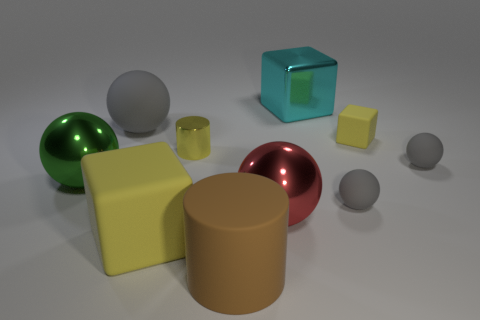What is the shape of the big rubber object that is the same color as the small metallic cylinder?
Make the answer very short. Cube. What number of cylinders are either big gray things or cyan shiny things?
Provide a succinct answer. 0. What number of gray objects have the same material as the yellow cylinder?
Provide a succinct answer. 0. Is the material of the block behind the big gray matte ball the same as the big thing in front of the big yellow thing?
Ensure brevity in your answer.  No. There is a large metal sphere to the left of the cylinder that is in front of the tiny yellow shiny object; what number of small yellow matte objects are in front of it?
Keep it short and to the point. 0. There is a small thing left of the large red ball; does it have the same color as the large cube that is in front of the big gray thing?
Provide a succinct answer. Yes. Is there any other thing that is the same color as the rubber cylinder?
Keep it short and to the point. No. There is a rubber block that is in front of the cylinder that is behind the big red metallic object; what is its color?
Your response must be concise. Yellow. Is there a blue rubber ball?
Your response must be concise. No. What color is the shiny thing that is behind the red thing and right of the brown thing?
Keep it short and to the point. Cyan. 